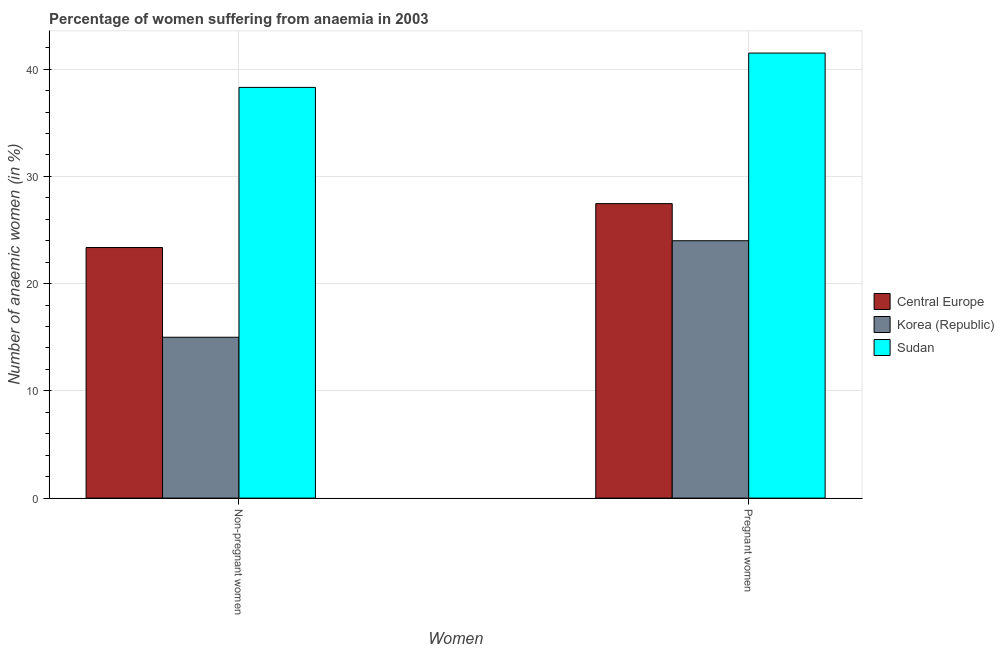How many different coloured bars are there?
Make the answer very short. 3. How many groups of bars are there?
Keep it short and to the point. 2. How many bars are there on the 1st tick from the right?
Your response must be concise. 3. What is the label of the 1st group of bars from the left?
Keep it short and to the point. Non-pregnant women. What is the percentage of non-pregnant anaemic women in Sudan?
Ensure brevity in your answer.  38.3. Across all countries, what is the maximum percentage of pregnant anaemic women?
Provide a short and direct response. 41.5. Across all countries, what is the minimum percentage of pregnant anaemic women?
Make the answer very short. 24. In which country was the percentage of pregnant anaemic women maximum?
Make the answer very short. Sudan. What is the total percentage of pregnant anaemic women in the graph?
Offer a very short reply. 92.96. What is the difference between the percentage of non-pregnant anaemic women in Korea (Republic) and that in Central Europe?
Offer a terse response. -8.37. What is the difference between the percentage of pregnant anaemic women in Korea (Republic) and the percentage of non-pregnant anaemic women in Central Europe?
Provide a succinct answer. 0.63. What is the average percentage of non-pregnant anaemic women per country?
Keep it short and to the point. 25.56. What is the ratio of the percentage of pregnant anaemic women in Central Europe to that in Korea (Republic)?
Provide a succinct answer. 1.14. Is the percentage of non-pregnant anaemic women in Korea (Republic) less than that in Central Europe?
Ensure brevity in your answer.  Yes. What does the 3rd bar from the left in Pregnant women represents?
Keep it short and to the point. Sudan. What does the 2nd bar from the right in Non-pregnant women represents?
Make the answer very short. Korea (Republic). Are all the bars in the graph horizontal?
Your answer should be very brief. No. What is the difference between two consecutive major ticks on the Y-axis?
Your response must be concise. 10. Does the graph contain any zero values?
Your response must be concise. No. Where does the legend appear in the graph?
Keep it short and to the point. Center right. How many legend labels are there?
Your answer should be very brief. 3. How are the legend labels stacked?
Your answer should be compact. Vertical. What is the title of the graph?
Give a very brief answer. Percentage of women suffering from anaemia in 2003. Does "Mongolia" appear as one of the legend labels in the graph?
Ensure brevity in your answer.  No. What is the label or title of the X-axis?
Keep it short and to the point. Women. What is the label or title of the Y-axis?
Your response must be concise. Number of anaemic women (in %). What is the Number of anaemic women (in %) in Central Europe in Non-pregnant women?
Your answer should be very brief. 23.37. What is the Number of anaemic women (in %) of Sudan in Non-pregnant women?
Provide a succinct answer. 38.3. What is the Number of anaemic women (in %) in Central Europe in Pregnant women?
Keep it short and to the point. 27.46. What is the Number of anaemic women (in %) in Korea (Republic) in Pregnant women?
Offer a terse response. 24. What is the Number of anaemic women (in %) in Sudan in Pregnant women?
Provide a succinct answer. 41.5. Across all Women, what is the maximum Number of anaemic women (in %) of Central Europe?
Your response must be concise. 27.46. Across all Women, what is the maximum Number of anaemic women (in %) in Sudan?
Give a very brief answer. 41.5. Across all Women, what is the minimum Number of anaemic women (in %) of Central Europe?
Offer a very short reply. 23.37. Across all Women, what is the minimum Number of anaemic women (in %) of Sudan?
Your answer should be very brief. 38.3. What is the total Number of anaemic women (in %) of Central Europe in the graph?
Offer a terse response. 50.83. What is the total Number of anaemic women (in %) of Sudan in the graph?
Make the answer very short. 79.8. What is the difference between the Number of anaemic women (in %) of Central Europe in Non-pregnant women and that in Pregnant women?
Ensure brevity in your answer.  -4.09. What is the difference between the Number of anaemic women (in %) of Sudan in Non-pregnant women and that in Pregnant women?
Your response must be concise. -3.2. What is the difference between the Number of anaemic women (in %) of Central Europe in Non-pregnant women and the Number of anaemic women (in %) of Korea (Republic) in Pregnant women?
Offer a very short reply. -0.63. What is the difference between the Number of anaemic women (in %) in Central Europe in Non-pregnant women and the Number of anaemic women (in %) in Sudan in Pregnant women?
Your answer should be compact. -18.13. What is the difference between the Number of anaemic women (in %) in Korea (Republic) in Non-pregnant women and the Number of anaemic women (in %) in Sudan in Pregnant women?
Offer a very short reply. -26.5. What is the average Number of anaemic women (in %) in Central Europe per Women?
Provide a short and direct response. 25.41. What is the average Number of anaemic women (in %) of Sudan per Women?
Your response must be concise. 39.9. What is the difference between the Number of anaemic women (in %) in Central Europe and Number of anaemic women (in %) in Korea (Republic) in Non-pregnant women?
Provide a succinct answer. 8.37. What is the difference between the Number of anaemic women (in %) in Central Europe and Number of anaemic women (in %) in Sudan in Non-pregnant women?
Keep it short and to the point. -14.93. What is the difference between the Number of anaemic women (in %) of Korea (Republic) and Number of anaemic women (in %) of Sudan in Non-pregnant women?
Your answer should be compact. -23.3. What is the difference between the Number of anaemic women (in %) of Central Europe and Number of anaemic women (in %) of Korea (Republic) in Pregnant women?
Offer a terse response. 3.46. What is the difference between the Number of anaemic women (in %) of Central Europe and Number of anaemic women (in %) of Sudan in Pregnant women?
Your answer should be very brief. -14.04. What is the difference between the Number of anaemic women (in %) of Korea (Republic) and Number of anaemic women (in %) of Sudan in Pregnant women?
Make the answer very short. -17.5. What is the ratio of the Number of anaemic women (in %) of Central Europe in Non-pregnant women to that in Pregnant women?
Provide a short and direct response. 0.85. What is the ratio of the Number of anaemic women (in %) of Korea (Republic) in Non-pregnant women to that in Pregnant women?
Your answer should be compact. 0.62. What is the ratio of the Number of anaemic women (in %) in Sudan in Non-pregnant women to that in Pregnant women?
Provide a short and direct response. 0.92. What is the difference between the highest and the second highest Number of anaemic women (in %) of Central Europe?
Give a very brief answer. 4.09. What is the difference between the highest and the second highest Number of anaemic women (in %) of Sudan?
Offer a very short reply. 3.2. What is the difference between the highest and the lowest Number of anaemic women (in %) in Central Europe?
Keep it short and to the point. 4.09. What is the difference between the highest and the lowest Number of anaemic women (in %) in Korea (Republic)?
Your answer should be very brief. 9. What is the difference between the highest and the lowest Number of anaemic women (in %) in Sudan?
Keep it short and to the point. 3.2. 